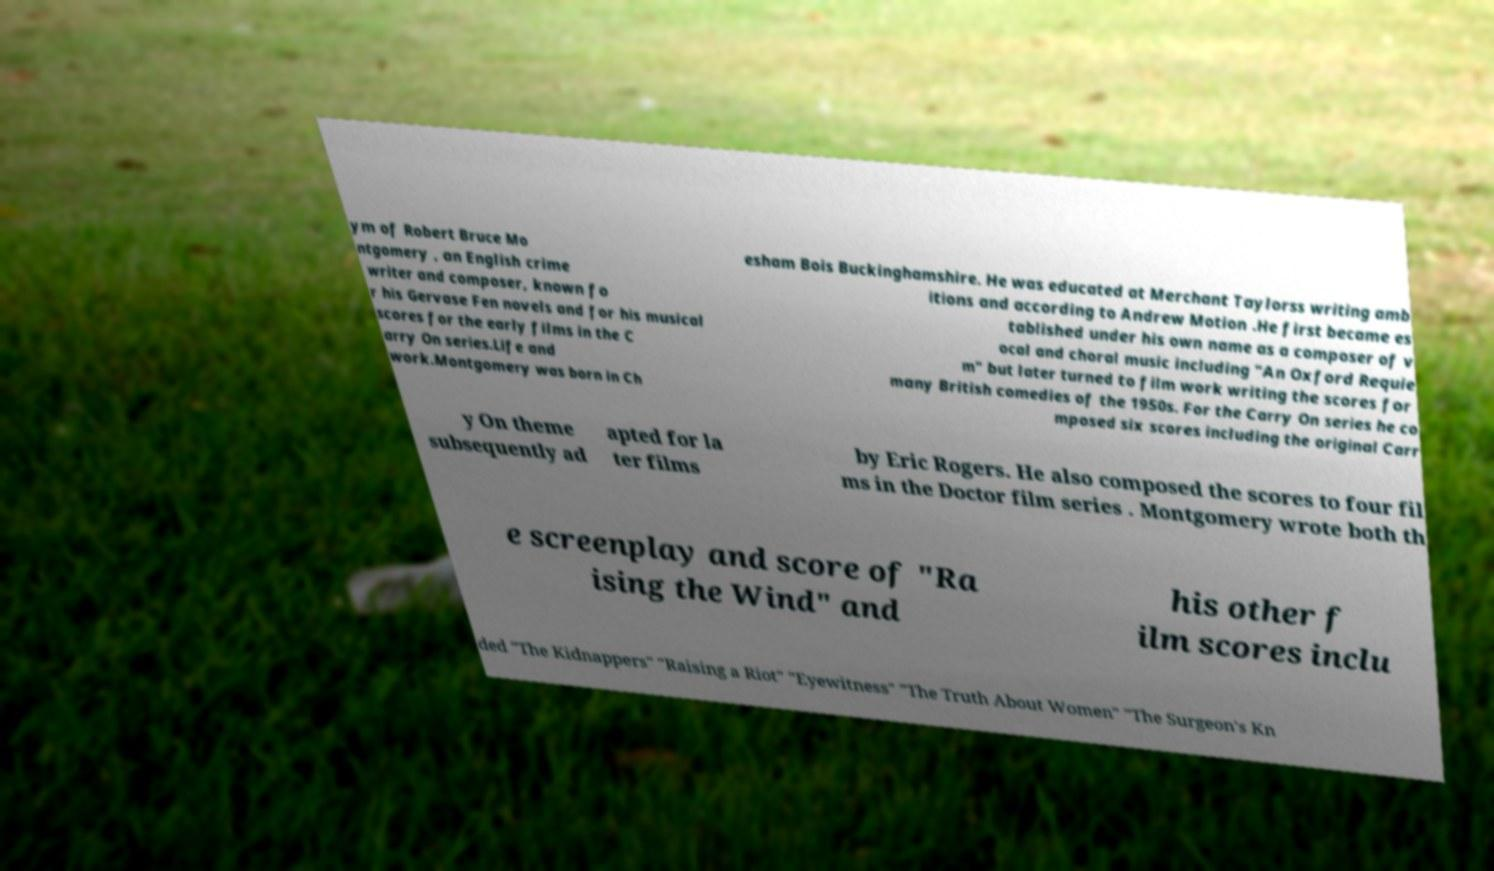Can you accurately transcribe the text from the provided image for me? ym of Robert Bruce Mo ntgomery , an English crime writer and composer, known fo r his Gervase Fen novels and for his musical scores for the early films in the C arry On series.Life and work.Montgomery was born in Ch esham Bois Buckinghamshire. He was educated at Merchant Taylorss writing amb itions and according to Andrew Motion .He first became es tablished under his own name as a composer of v ocal and choral music including "An Oxford Requie m" but later turned to film work writing the scores for many British comedies of the 1950s. For the Carry On series he co mposed six scores including the original Carr y On theme subsequently ad apted for la ter films by Eric Rogers. He also composed the scores to four fil ms in the Doctor film series . Montgomery wrote both th e screenplay and score of "Ra ising the Wind" and his other f ilm scores inclu ded "The Kidnappers" "Raising a Riot" "Eyewitness" "The Truth About Women" "The Surgeon's Kn 